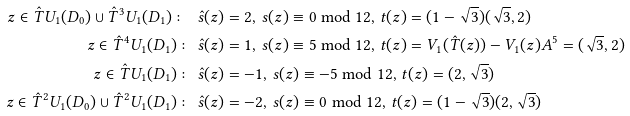<formula> <loc_0><loc_0><loc_500><loc_500>z \in \hat { T } U _ { 1 } ( D _ { 0 } ) \cup \hat { T } ^ { 3 } U _ { 1 } ( D _ { 1 } ) \colon \ & \hat { s } ( z ) = 2 , \, s ( z ) \equiv 0 \bmod 1 2 , \, t ( z ) = ( 1 - \sqrt { 3 } ) ( \sqrt { 3 } , 2 ) \\ z \in \hat { T } ^ { 4 } U _ { 1 } ( D _ { 1 } ) \colon \ & \hat { s } ( z ) = 1 , \, s ( z ) \equiv 5 \bmod 1 2 , \, t ( z ) = V _ { 1 } ( \hat { T } ( z ) ) - V _ { 1 } ( z ) A ^ { 5 } = ( \sqrt { 3 } , 2 ) \\ z \in \hat { T } U _ { 1 } ( D _ { 1 } ) \colon \ & \hat { s } ( z ) = - 1 , \, s ( z ) \equiv - 5 \bmod 1 2 , \, t ( z ) = ( 2 , \sqrt { 3 } ) \\ z \in \hat { T } ^ { 2 } U _ { 1 } ( D _ { 0 } ) \cup \hat { T } ^ { 2 } U _ { 1 } ( D _ { 1 } ) \colon \ & \hat { s } ( z ) = - 2 , \, s ( z ) \equiv 0 \bmod 1 2 , \, t ( z ) = ( 1 - \sqrt { 3 } ) ( 2 , \sqrt { 3 } )</formula> 